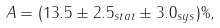Convert formula to latex. <formula><loc_0><loc_0><loc_500><loc_500>A = ( 1 3 . 5 \pm 2 . 5 _ { s t a t } \pm 3 . 0 _ { s y s } ) \% ,</formula> 